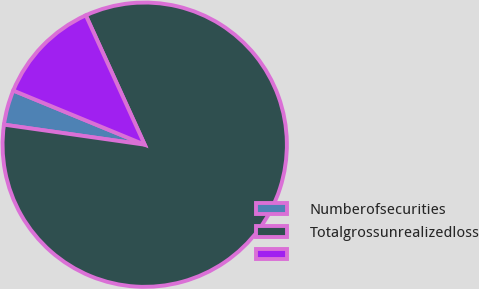Convert chart. <chart><loc_0><loc_0><loc_500><loc_500><pie_chart><fcel>Numberofsecurities<fcel>Totalgrossunrealizedloss<fcel>Unnamed: 2<nl><fcel>3.97%<fcel>84.05%<fcel>11.98%<nl></chart> 